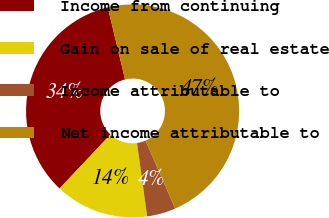Convert chart. <chart><loc_0><loc_0><loc_500><loc_500><pie_chart><fcel>Income from continuing<fcel>Gain on sale of real estate<fcel>Income attributable to<fcel>Net income attributable to<nl><fcel>34.24%<fcel>14.2%<fcel>4.37%<fcel>47.18%<nl></chart> 